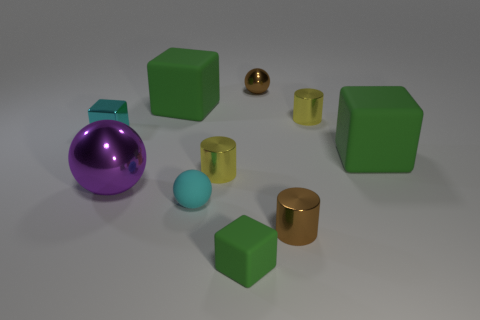Does the purple shiny ball have the same size as the yellow shiny cylinder that is on the right side of the tiny green rubber block?
Keep it short and to the point. No. There is a metal ball left of the matte ball; does it have the same size as the green matte object that is in front of the small brown cylinder?
Make the answer very short. No. What size is the matte cube that is left of the cyan rubber sphere?
Keep it short and to the point. Large. There is a brown metal object behind the tiny cyan object that is in front of the shiny cube; what size is it?
Your response must be concise. Small. There is a green cube that is the same size as the matte sphere; what material is it?
Offer a very short reply. Rubber. Is the number of large purple metal things that are behind the small brown ball the same as the number of tiny purple metallic things?
Your answer should be compact. Yes. The cyan object that is the same size as the metallic cube is what shape?
Ensure brevity in your answer.  Sphere. What material is the brown cylinder?
Give a very brief answer. Metal. What is the color of the small shiny thing that is in front of the tiny cyan metal block and to the left of the tiny metal ball?
Your response must be concise. Yellow. Are there the same number of brown cylinders that are behind the tiny green thing and big metallic spheres that are in front of the brown shiny sphere?
Ensure brevity in your answer.  Yes. 